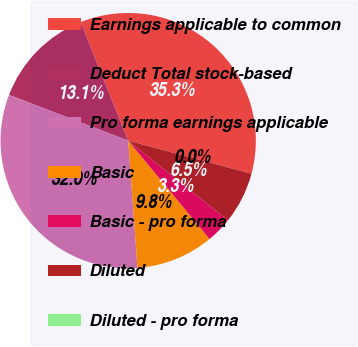Convert chart to OTSL. <chart><loc_0><loc_0><loc_500><loc_500><pie_chart><fcel>Earnings applicable to common<fcel>Deduct Total stock-based<fcel>Pro forma earnings applicable<fcel>Basic<fcel>Basic - pro forma<fcel>Diluted<fcel>Diluted - pro forma<nl><fcel>35.26%<fcel>13.1%<fcel>31.99%<fcel>9.83%<fcel>3.28%<fcel>6.55%<fcel>0.0%<nl></chart> 